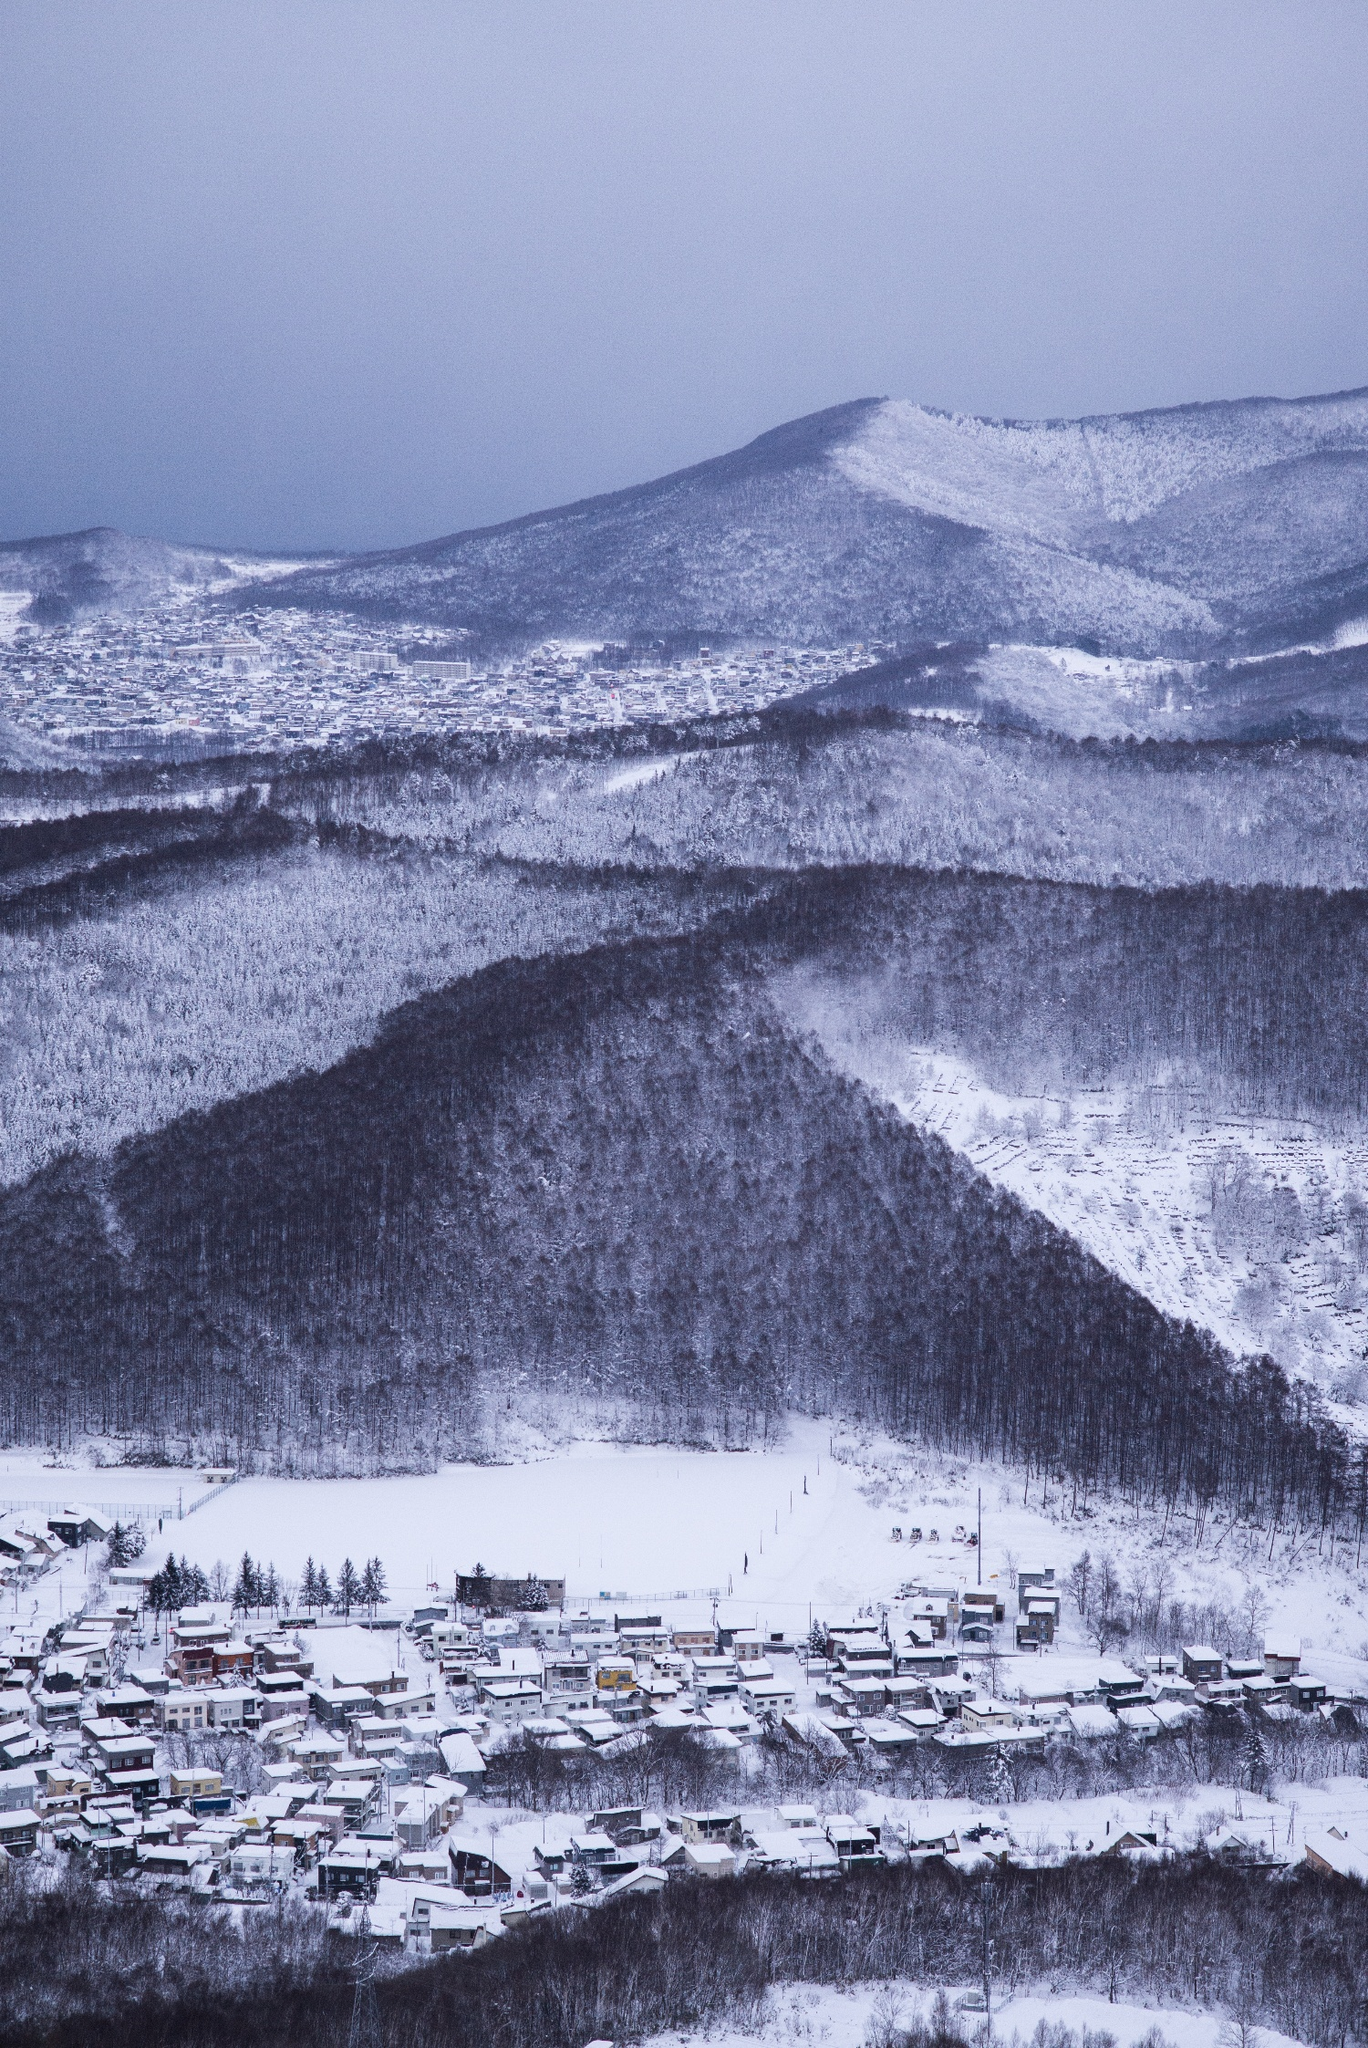How does the architecture of the buildings help in dealing with the heavy snowfall? The architecture in the town likely incorporates features designed to withstand and adapt to heavy snowfall. Steeply pitched roofs are a common design, allowing snow to slide off rather than accumulate and pose a risk of collapse. The buildings might be constructed with durable, insulating materials to retain heat and reduce energy costs. Additionally, the compact layout of the town suggests a design philosophy that minimizes exposure to the elements and facilitates easier maintenance during winter. 